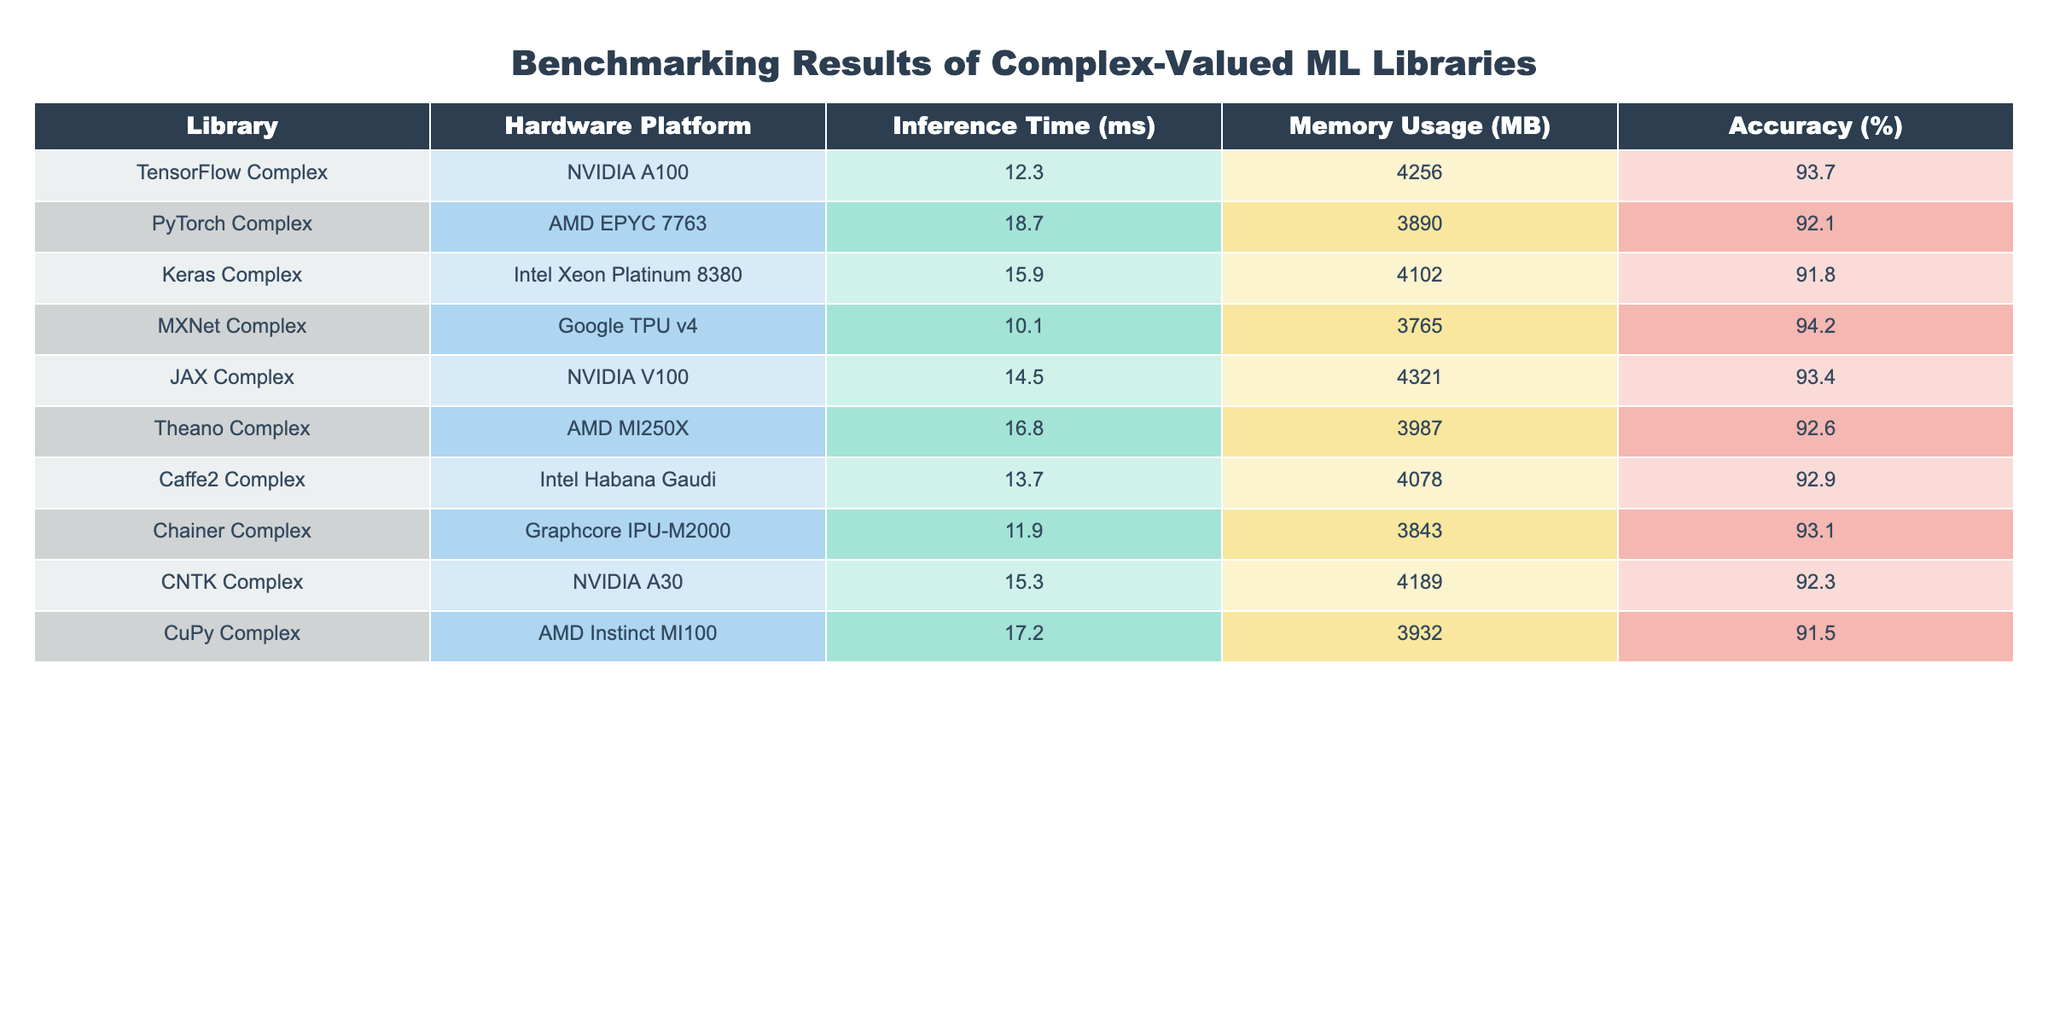What is the inference time for TensorFlow Complex on NVIDIA A100? The table shows that the inference time for TensorFlow Complex on NVIDIA A100 is listed directly under the "Inference Time (ms)" column. Looking at the entry for TensorFlow Complex, the value is 12.3 ms.
Answer: 12.3 ms Which library has the highest memory usage? By reviewing the "Memory Usage (MB)" column in the table, we compare the memory usages of all libraries. TensorFlow Complex has the highest value, which is 4256 MB.
Answer: 4256 MB What is the accuracy of MXNet Complex on Google TPU v4? The accuracy value is found directly in the table under the "Accuracy (%)" column for MXNet Complex, which is 94.2%.
Answer: 94.2% Which library shows the best accuracy among all hardware platforms? We need to check the accuracy percentages for each library. MXNet Complex has the highest accuracy at 94.2%, which is greater than that of all other libraries listed.
Answer: MXNet Complex What is the average inference time of the libraries on NVIDIA hardware platforms? We identify the libraries running on NVIDIA hardware: TensorFlow Complex (12.3 ms), JAX Complex (14.5 ms), and CNTK Complex (15.3 ms). We sum these times: 12.3 + 14.5 + 15.3 = 42.1 ms. We then divide this sum by 3 (the number of libraries): 42.1 / 3 = 14.03 ms.
Answer: 14.03 ms Is the accuracy for CuPy Complex greater than 91%? We look at the accuracy of CuPy Complex from the table, which is 91.5%. Since 91.5% is greater than 91%, we conclude that the statement is true.
Answer: Yes Which library has the second lowest inference time, and what is that time? We need to look through the "Inference Time (ms)" column in the table. The lowest is MXNet (10.1 ms), and the second lowest is Chainer Complex (11.9 ms). The inference time for Chainer is 11.9 ms.
Answer: Chainer Complex, 11.9 ms What is the difference in accuracy between JAX Complex and Theano Complex? We find the accuracy of JAX Complex (93.4%) and Theano Complex (92.6%) in the table. To find the difference, we subtract Theano's accuracy from JAX's: 93.4% - 92.6% = 0.8%.
Answer: 0.8% Which library has the lowest memory usage, and what is the value? We need to review the "Memory Usage (MB)" column for all libraries. Chainer Complex has the lowest memory usage at 3843 MB.
Answer: Chainer Complex, 3843 MB What is the total memory usage of all libraries listed? We can sum the memory usage for each library from the table: 4256 + 3890 + 4102 + 3765 + 4321 + 3987 + 4078 + 3843 + 3932 = 33,174 MB. Hence, the total memory usage is 33,174 MB.
Answer: 33,174 MB 